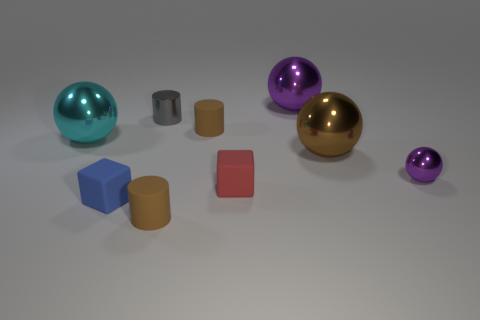Does the gray cylinder have the same size as the cyan metallic ball to the left of the small red rubber cube?
Provide a succinct answer. No. There is a matte object that is behind the cyan metallic object; what color is it?
Make the answer very short. Brown. There is a object that is the same color as the tiny metallic ball; what is its shape?
Keep it short and to the point. Sphere. There is a rubber object to the left of the gray thing; what shape is it?
Keep it short and to the point. Cube. How many gray objects are either spheres or matte cylinders?
Make the answer very short. 0. Do the big purple thing and the large cyan sphere have the same material?
Give a very brief answer. Yes. How many tiny objects are on the right side of the tiny purple shiny sphere?
Make the answer very short. 0. What is the thing that is both right of the red thing and in front of the big brown shiny object made of?
Make the answer very short. Metal. What number of cylinders are either yellow things or tiny purple objects?
Provide a short and direct response. 0. There is a large purple thing that is the same shape as the large brown metallic thing; what material is it?
Your answer should be compact. Metal. 